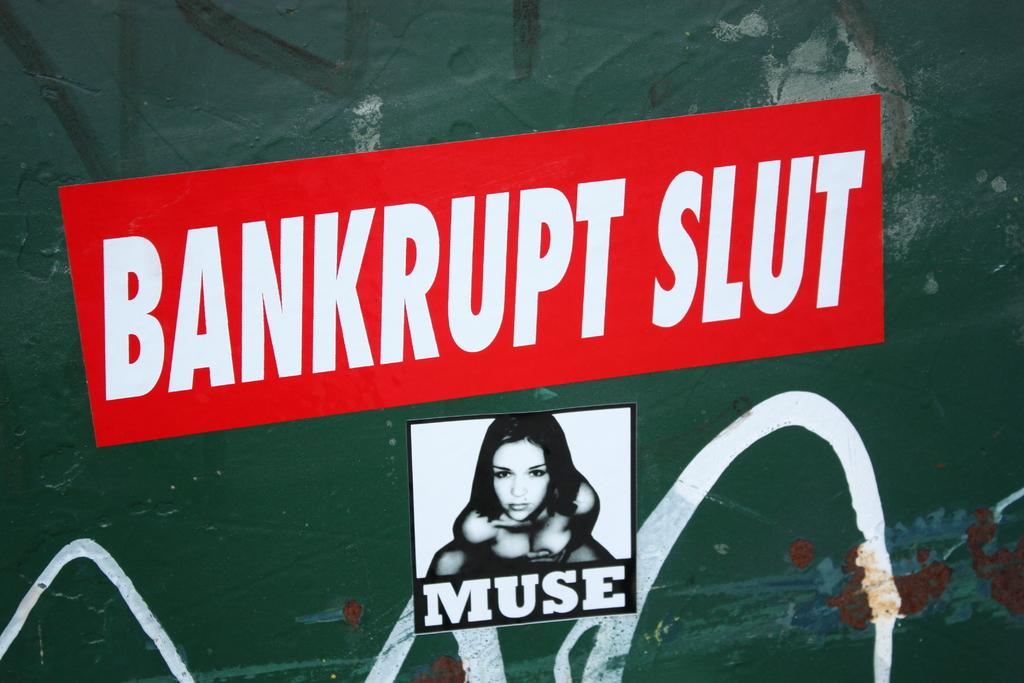<image>
Relay a brief, clear account of the picture shown. Two stickers on a green wall with spray paint and one mentions bankruptcy 